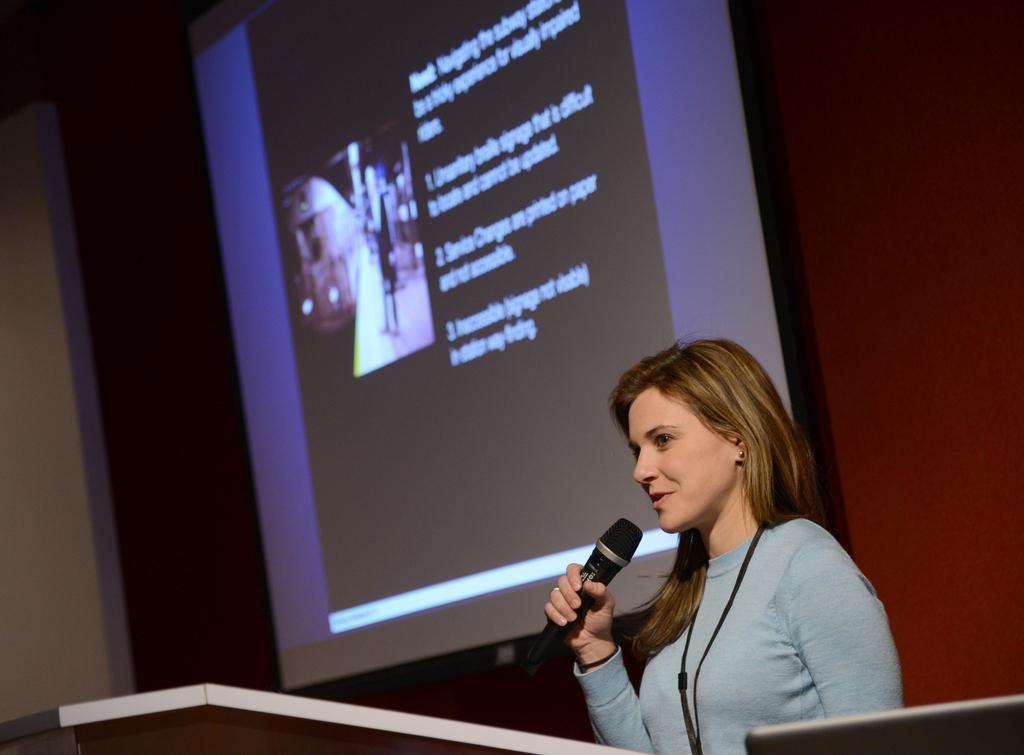In one or two sentences, can you explain what this image depicts? In this picture we can see woman holding mic in her hand and talking and in background we can see screen with slides, wall. 